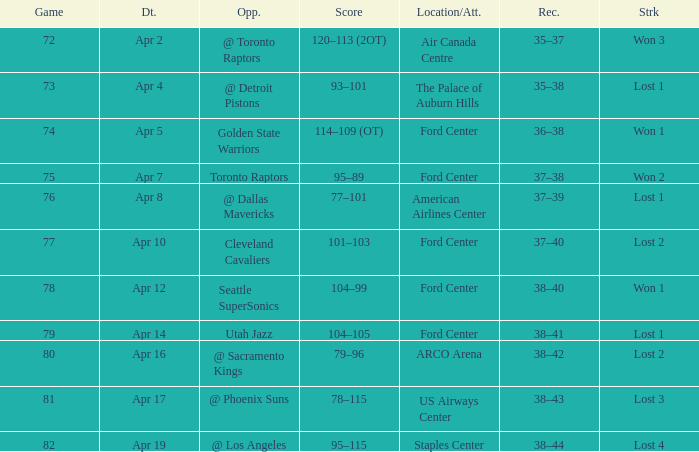What was the record for less than 78 games and a score of 114–109 (ot)? 36–38. 